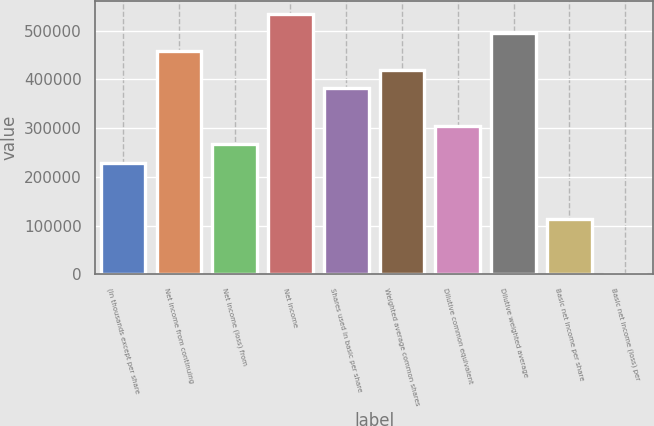Convert chart. <chart><loc_0><loc_0><loc_500><loc_500><bar_chart><fcel>(In thousands except per share<fcel>Net income from continuing<fcel>Net income (loss) from<fcel>Net income<fcel>Shares used in basic per share<fcel>Weighted average common shares<fcel>Dilutive common equivalent<fcel>Dilutive weighted average<fcel>Basic net income per share<fcel>Basic net income (loss) per<nl><fcel>228976<fcel>457952<fcel>267139<fcel>534278<fcel>381627<fcel>419790<fcel>305302<fcel>496115<fcel>114488<fcel>0.02<nl></chart> 